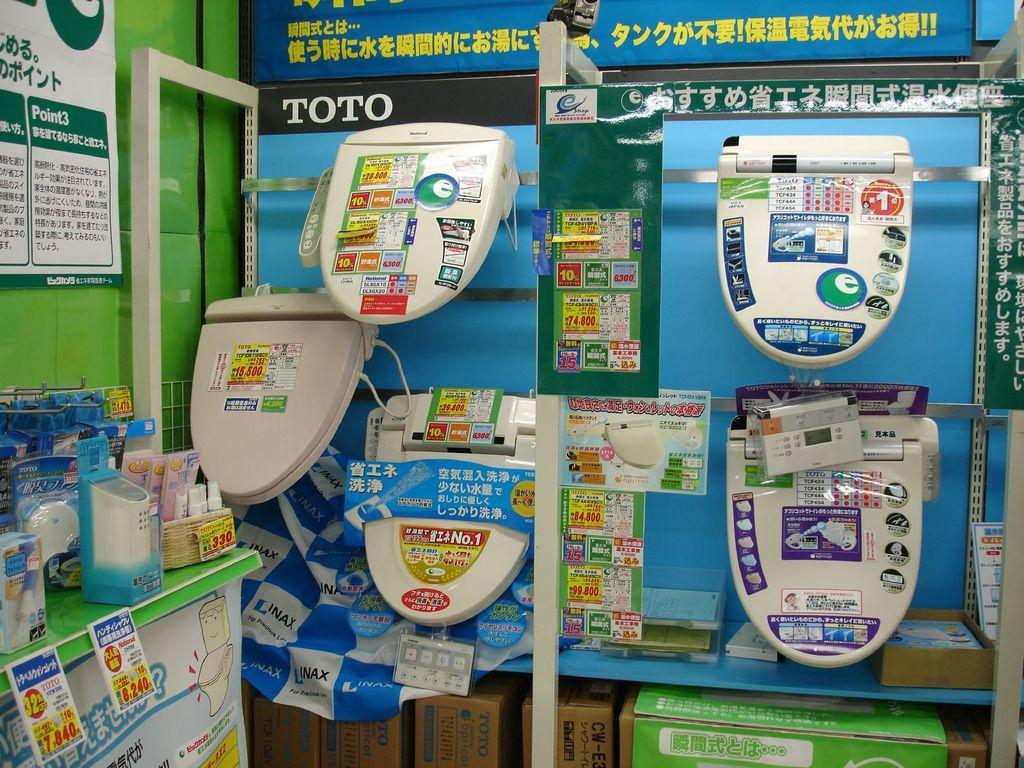Provide a one-sentence caption for the provided image. A lot of toilet lids hanging on a display with the word Toto nearby. 